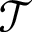Convert formula to latex. <formula><loc_0><loc_0><loc_500><loc_500>\mathcal { T }</formula> 